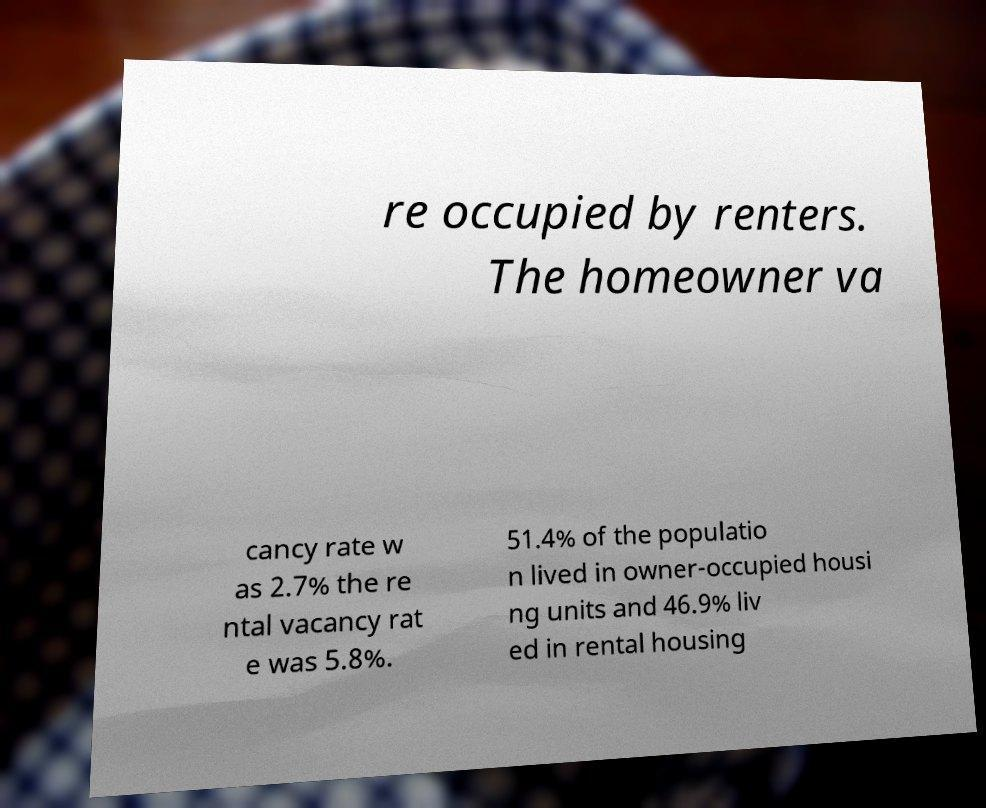I need the written content from this picture converted into text. Can you do that? re occupied by renters. The homeowner va cancy rate w as 2.7% the re ntal vacancy rat e was 5.8%. 51.4% of the populatio n lived in owner-occupied housi ng units and 46.9% liv ed in rental housing 